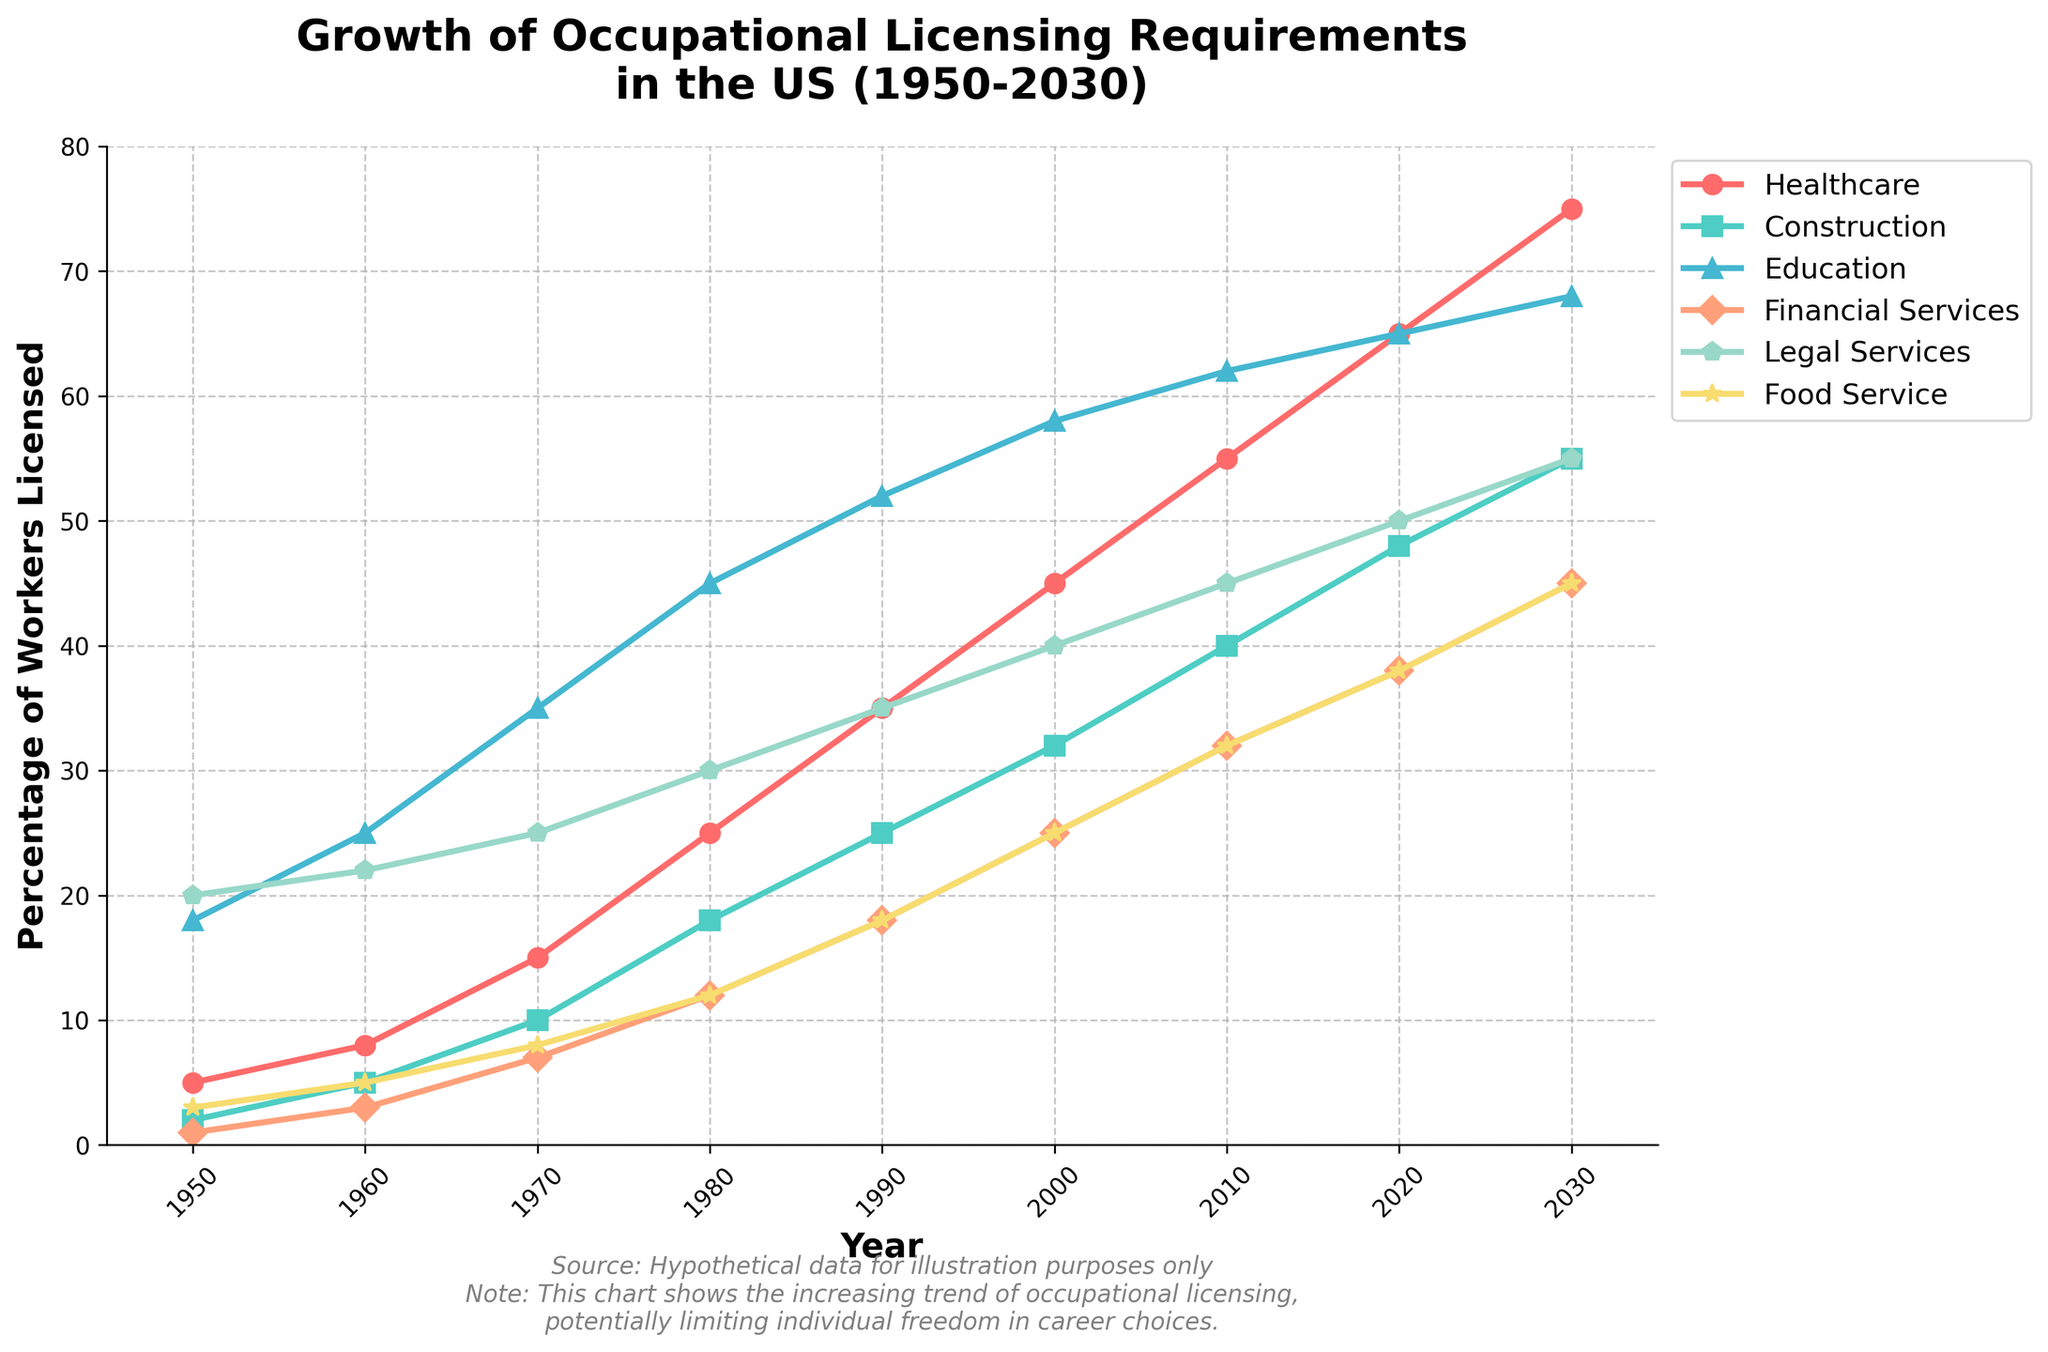What is the overall trend in occupational licensing requirements for Healthcare from 1950 to 2030? The line for Healthcare steadily rises from 5% in 1950 to 75% in 2030, indicating a consistent increase over time.
Answer: Increasing Which industry had the highest percentage of workers licensed in 1970? In 1970, Legal Services had the highest percentage at 25% compared to other industries.
Answer: Legal Services How much did the licensing percentage in Construction increase between 1980 and 2000? According to the chart, Construction's licensing percentage increased from 18% in 1980 to 32% in 2000, a difference of 14%.
Answer: 14% Which industry had the slowest growth in licensing requirements from 1950 to 2030? By comparing the lengths of the lines, Financial Services started at 1% in 1950 and increased to 45% by 2030, which appears to be the slowest growth among the industries shown.
Answer: Financial Services In what year did Food Service licensing requirements reach 32%? In the chart, Food Service’s licensing percentage reached 32% in the year 2010.
Answer: 2010 Which two industries had equal licensing percentages in 1990 and what were those percentages? In 1990, both Financial Services and Food Service had licensing percentages of 18%.
Answer: Financial Services and Food Service, 18% What is the difference in licensing percentages between Education and Healthcare in 1980? Education had a licensing percentage of 45% and Healthcare had 25% in 1980, resulting in a difference of 20%.
Answer: 20% Compare the trends of Healthcare and Legal Services from 2000 to 2020. Which one grew faster? From 2000 to 2020, Healthcare grew from 45% to 65% (an increase of 20%), while Legal Services grew from 40% to 50% (an increase of 10%). Healthcare grew faster.
Answer: Healthcare What was the growth rate of licensing requirements for Healthcare from 1950 to 1960? Healthcare increased from 5% in 1950 to 8% in 1960. The growth rate is (8-5)/5 * 100 = 60%.
Answer: 60% In which year did Construction's licensing requirements exceed 50%? According to the chart, Construction's licensing requirements exceeded 50% in the year 2030.
Answer: 2030 